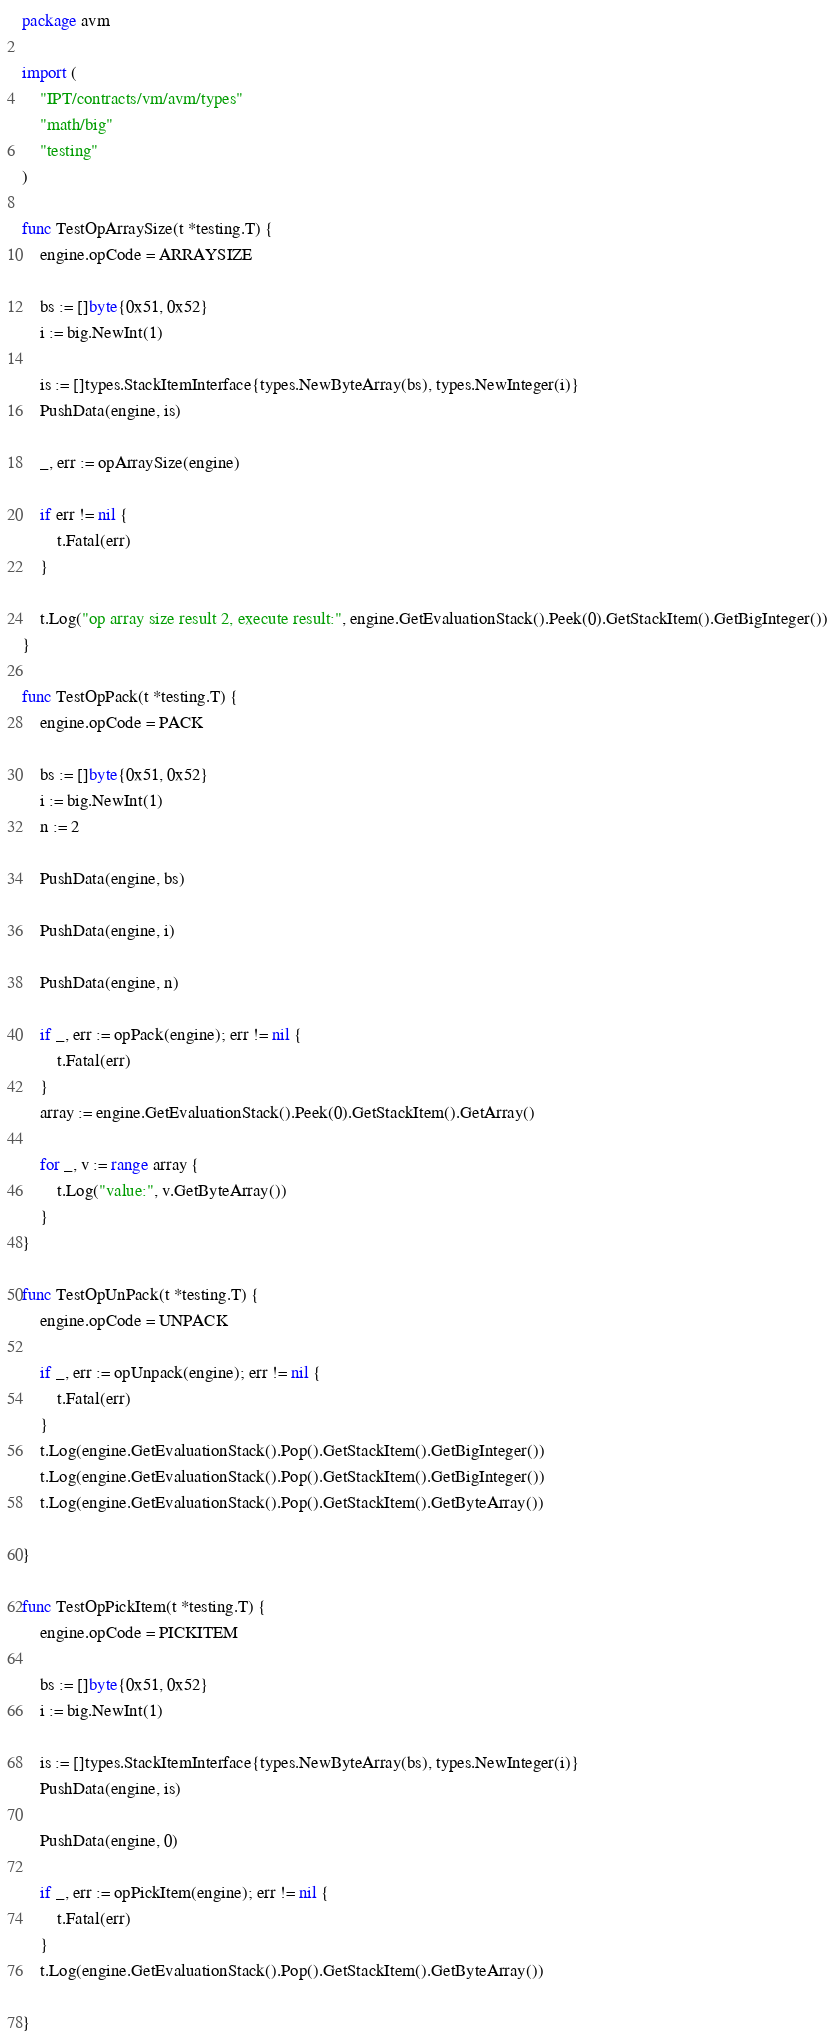Convert code to text. <code><loc_0><loc_0><loc_500><loc_500><_Go_>package avm

import (
	"IPT/contracts/vm/avm/types"
	"math/big"
	"testing"
)

func TestOpArraySize(t *testing.T) {
	engine.opCode = ARRAYSIZE

	bs := []byte{0x51, 0x52}
	i := big.NewInt(1)

	is := []types.StackItemInterface{types.NewByteArray(bs), types.NewInteger(i)}
	PushData(engine, is)

	_, err := opArraySize(engine)

	if err != nil {
		t.Fatal(err)
	}

	t.Log("op array size result 2, execute result:", engine.GetEvaluationStack().Peek(0).GetStackItem().GetBigInteger())
}

func TestOpPack(t *testing.T) {
	engine.opCode = PACK

	bs := []byte{0x51, 0x52}
	i := big.NewInt(1)
	n := 2

	PushData(engine, bs)

	PushData(engine, i)

	PushData(engine, n)

	if _, err := opPack(engine); err != nil {
		t.Fatal(err)
	}
	array := engine.GetEvaluationStack().Peek(0).GetStackItem().GetArray()

	for _, v := range array {
		t.Log("value:", v.GetByteArray())
	}
}

func TestOpUnPack(t *testing.T) {
	engine.opCode = UNPACK

	if _, err := opUnpack(engine); err != nil {
		t.Fatal(err)
	}
	t.Log(engine.GetEvaluationStack().Pop().GetStackItem().GetBigInteger())
	t.Log(engine.GetEvaluationStack().Pop().GetStackItem().GetBigInteger())
	t.Log(engine.GetEvaluationStack().Pop().GetStackItem().GetByteArray())

}

func TestOpPickItem(t *testing.T) {
	engine.opCode = PICKITEM

	bs := []byte{0x51, 0x52}
	i := big.NewInt(1)

	is := []types.StackItemInterface{types.NewByteArray(bs), types.NewInteger(i)}
	PushData(engine, is)

	PushData(engine, 0)

	if _, err := opPickItem(engine); err != nil {
		t.Fatal(err)
	}
	t.Log(engine.GetEvaluationStack().Pop().GetStackItem().GetByteArray())

}
</code> 